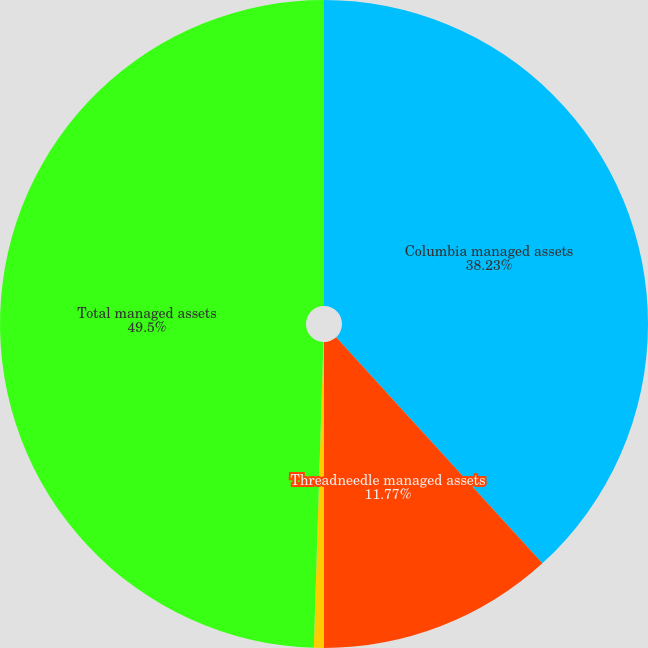Convert chart to OTSL. <chart><loc_0><loc_0><loc_500><loc_500><pie_chart><fcel>Columbia managed assets<fcel>Threadneedle managed assets<fcel>Less Sub-advised eliminations<fcel>Total managed assets<nl><fcel>38.23%<fcel>11.77%<fcel>0.5%<fcel>49.5%<nl></chart> 